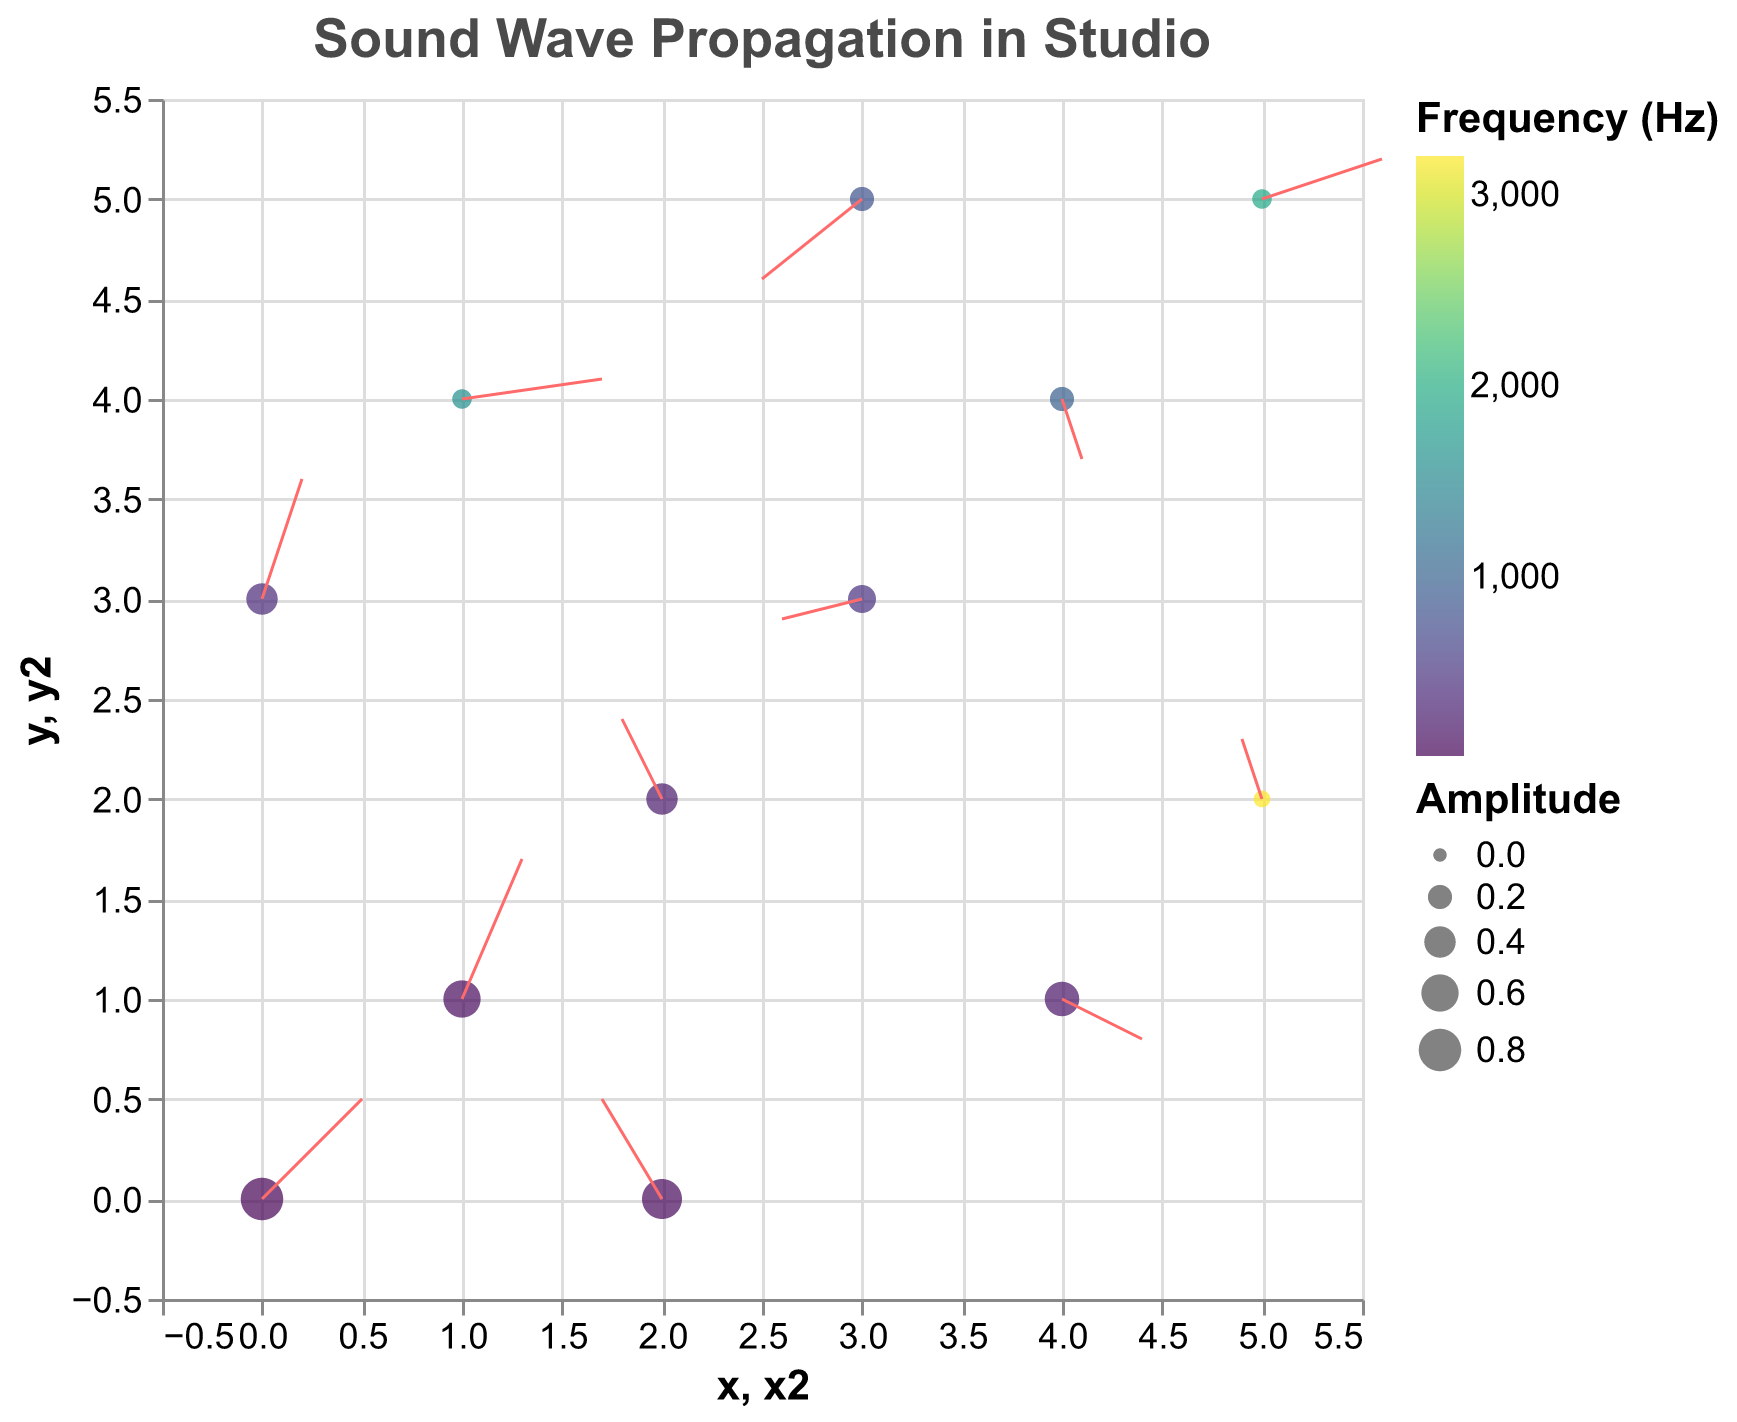What's the title of the figure? The title of the figure is provided at the top and indicates what the plot represents.
Answer: Sound Wave Propagation in Studio What does the color of the points represent? The color of the points represents the frequency of the sound waves, as indicated by the color legend.
Answer: Frequency Which point has the highest amplitude? The size legend indicates that bigger points represent higher amplitude. The largest point is at coordinates (0, 0).
Answer: (0, 0) What are the values of x and y for the point with a frequency of 1920 Hz? By matching the frequency in the legend to the plot, the point with 1920 Hz is located at coordinates (5, 5).
Answer: (5, 5) How do the u and v vectors change for the highest frequency point? The highest frequency point has a frequency of 3200 Hz; its coordinates are (5, 2) with initial u and v values of -0.1 and 0.3. These vectors point slightly leftwards and upwards, directing the sound-wave movement.
Answer: Leftwards and upwards What is the total amplitude of the points with a frequency less than 500 Hz? Frequency less than 500 Hz includes 60, 100, 120, 200, 240, and 400 Hz, with amplitudes 0.8, 0.7, 0.6, 0.5, 0.4, and 0.4 respectively. The total is 0.8 + 0.7 + 0.6 + 0.5 + 0.4 + 0.4 = 3.4.
Answer: 3.4 Compare the direction of movement for the points (3, 3) and (4, 1). Which one shows a more downward trend? For (3, 3), the arrows point slightly downward (u,v = -0.4, -0.1). For (4, 1), the arrows point more straight downward (u,v = 0.4, -0.2), indicating a more pronounced downward trend.
Answer: (4, 1) What is the average frequency of all the data points? Sum of all frequencies divided by the number of data points. Frequencies: 60, 120, 240, 480, 960, 1920, 100, 200, 400, 800, 1600, 3200. Total: 10080. Average: 10080 / 12 = 840.
Answer: 840 Which point has the longest vector (u, v)? The length of the vector is given by the magnitude (sqrt(u^2 + v^2)). The maximum-length vector is the one with u = 0.3 and v = 0.7 (at coordinates 1, 1).
Answer: (1, 1) How many data points have an amplitude greater than 0.5? By visually comparing amplitudes, points with coordinates (0, 0), (1, 1), and (2, 0) have large enough sizes to have amplitudes greater than 0.5.
Answer: 3 